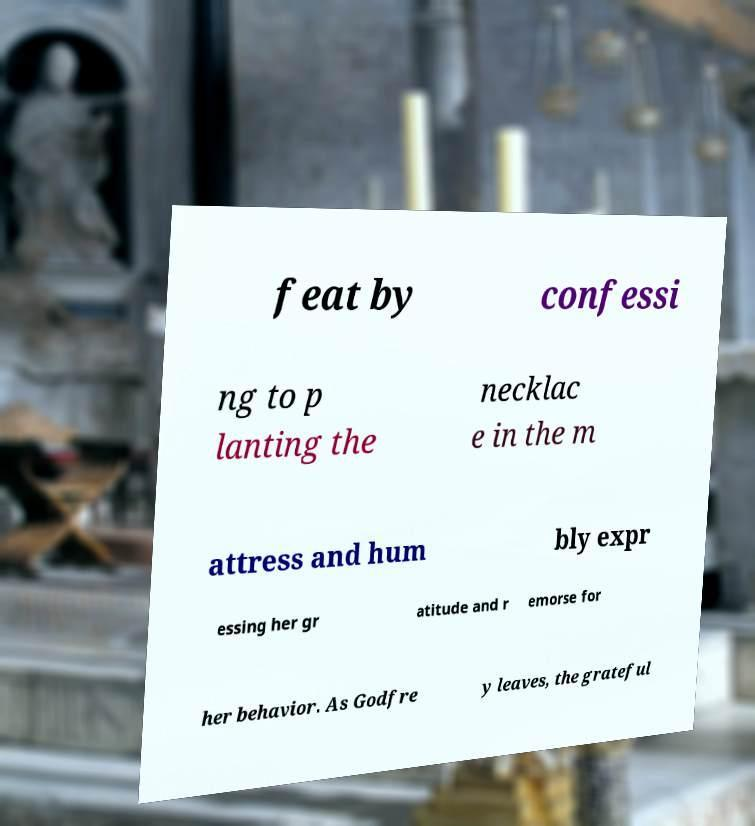Can you accurately transcribe the text from the provided image for me? feat by confessi ng to p lanting the necklac e in the m attress and hum bly expr essing her gr atitude and r emorse for her behavior. As Godfre y leaves, the grateful 